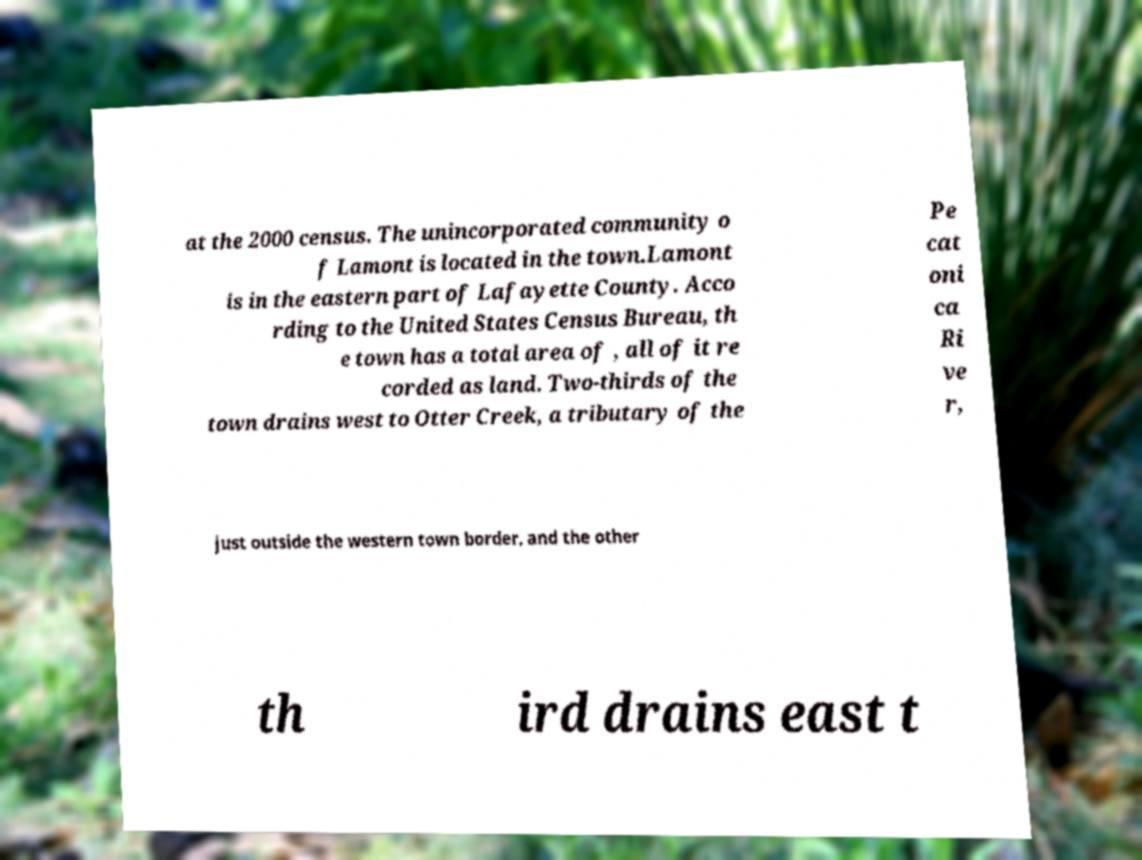Please read and relay the text visible in this image. What does it say? at the 2000 census. The unincorporated community o f Lamont is located in the town.Lamont is in the eastern part of Lafayette County. Acco rding to the United States Census Bureau, th e town has a total area of , all of it re corded as land. Two-thirds of the town drains west to Otter Creek, a tributary of the Pe cat oni ca Ri ve r, just outside the western town border, and the other th ird drains east t 